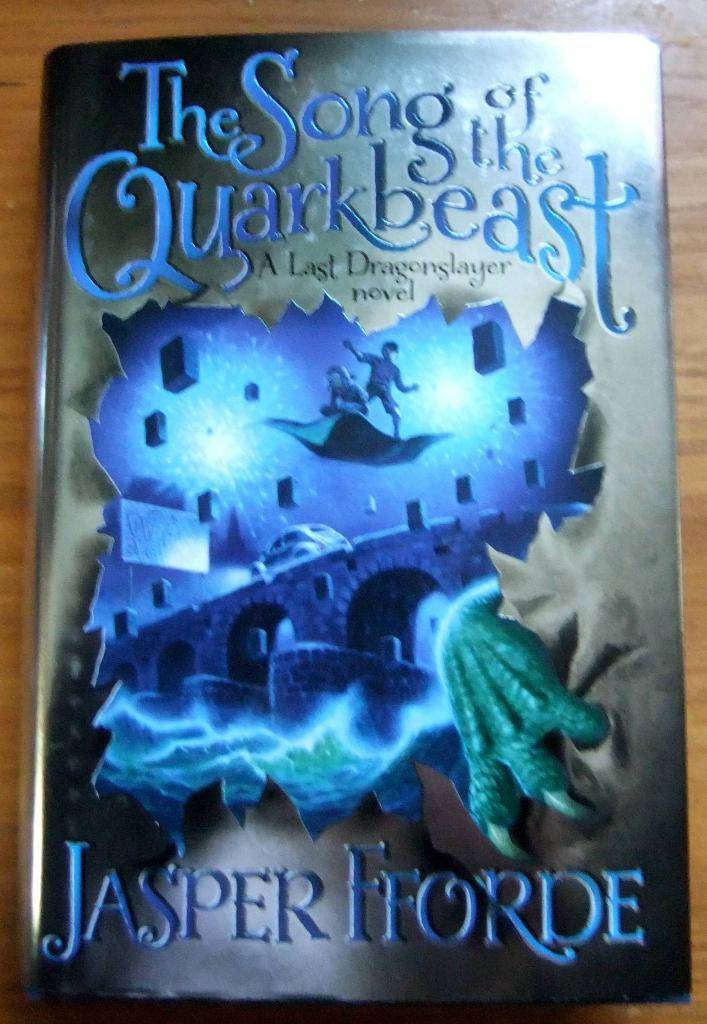<image>
Summarize the visual content of the image. The cover of The Song of the Quarkbeast by Jasper Fforde. 